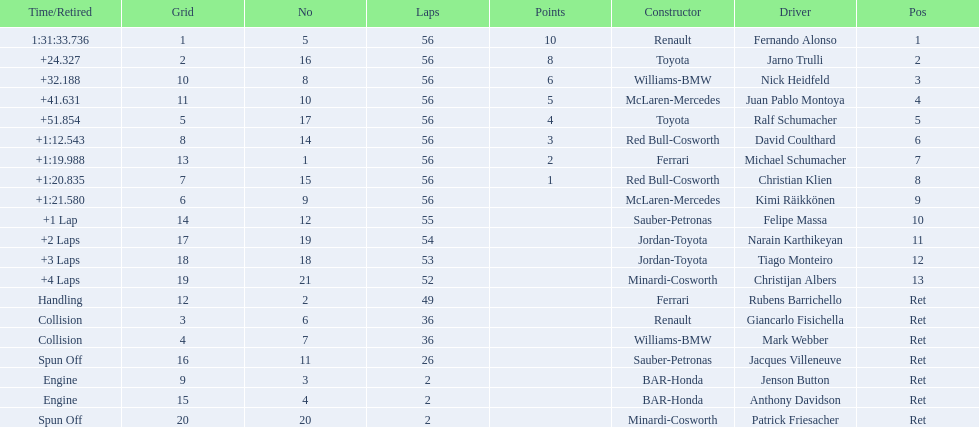Can you give me this table as a dict? {'header': ['Time/Retired', 'Grid', 'No', 'Laps', 'Points', 'Constructor', 'Driver', 'Pos'], 'rows': [['1:31:33.736', '1', '5', '56', '10', 'Renault', 'Fernando Alonso', '1'], ['+24.327', '2', '16', '56', '8', 'Toyota', 'Jarno Trulli', '2'], ['+32.188', '10', '8', '56', '6', 'Williams-BMW', 'Nick Heidfeld', '3'], ['+41.631', '11', '10', '56', '5', 'McLaren-Mercedes', 'Juan Pablo Montoya', '4'], ['+51.854', '5', '17', '56', '4', 'Toyota', 'Ralf Schumacher', '5'], ['+1:12.543', '8', '14', '56', '3', 'Red Bull-Cosworth', 'David Coulthard', '6'], ['+1:19.988', '13', '1', '56', '2', 'Ferrari', 'Michael Schumacher', '7'], ['+1:20.835', '7', '15', '56', '1', 'Red Bull-Cosworth', 'Christian Klien', '8'], ['+1:21.580', '6', '9', '56', '', 'McLaren-Mercedes', 'Kimi Räikkönen', '9'], ['+1 Lap', '14', '12', '55', '', 'Sauber-Petronas', 'Felipe Massa', '10'], ['+2 Laps', '17', '19', '54', '', 'Jordan-Toyota', 'Narain Karthikeyan', '11'], ['+3 Laps', '18', '18', '53', '', 'Jordan-Toyota', 'Tiago Monteiro', '12'], ['+4 Laps', '19', '21', '52', '', 'Minardi-Cosworth', 'Christijan Albers', '13'], ['Handling', '12', '2', '49', '', 'Ferrari', 'Rubens Barrichello', 'Ret'], ['Collision', '3', '6', '36', '', 'Renault', 'Giancarlo Fisichella', 'Ret'], ['Collision', '4', '7', '36', '', 'Williams-BMW', 'Mark Webber', 'Ret'], ['Spun Off', '16', '11', '26', '', 'Sauber-Petronas', 'Jacques Villeneuve', 'Ret'], ['Engine', '9', '3', '2', '', 'BAR-Honda', 'Jenson Button', 'Ret'], ['Engine', '15', '4', '2', '', 'BAR-Honda', 'Anthony Davidson', 'Ret'], ['Spun Off', '20', '20', '2', '', 'Minardi-Cosworth', 'Patrick Friesacher', 'Ret']]} How many drivers ended the race early because of engine problems? 2. 